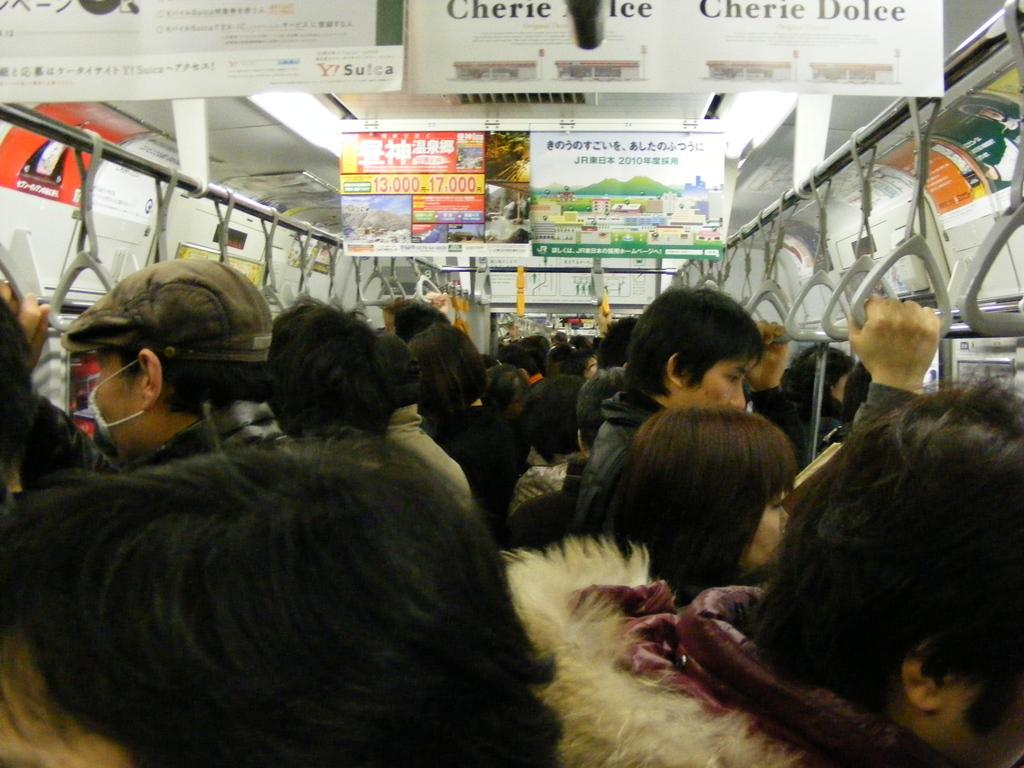What are the people in the image doing? The people in the image are standing in a train. How close are the people standing to each other? The people are standing tightly together. What are the people holding onto for support? The people are holding a ceiling rod with belts. What can be seen hanging from the ceiling in the image? There are boards hanging from the ceiling. What type of steel is used to make the pies in the image? There are no pies present in the image, and therefore no steel can be associated with them. 